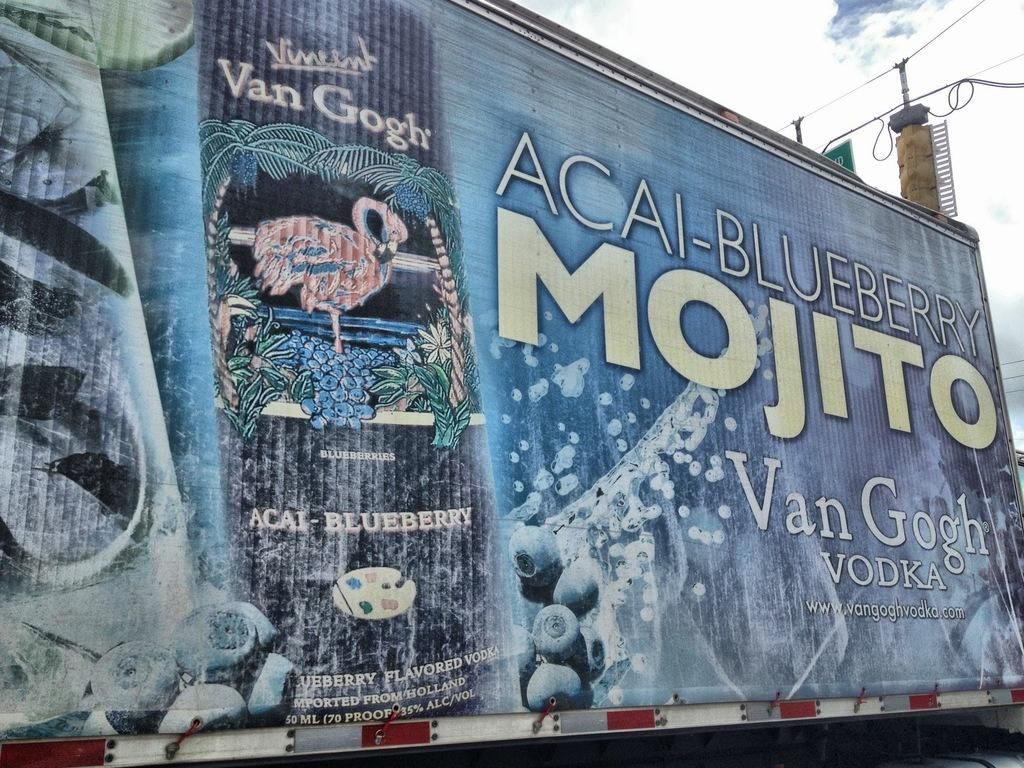<image>
Share a concise interpretation of the image provided. A billboard shows Van Gogh vodka and mojito. 